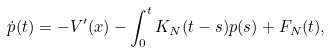Convert formula to latex. <formula><loc_0><loc_0><loc_500><loc_500>\dot { p } ( t ) = - V ^ { \prime } ( x ) - \int _ { 0 } ^ { t } K _ { N } ( t - s ) p ( s ) + F _ { N } ( t ) ,</formula> 